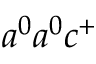Convert formula to latex. <formula><loc_0><loc_0><loc_500><loc_500>a ^ { 0 } a ^ { 0 } c ^ { + }</formula> 